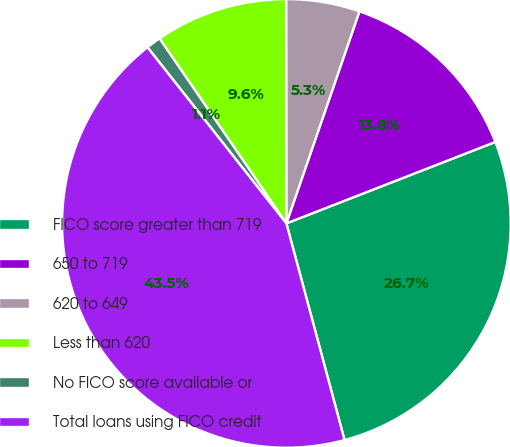Convert chart to OTSL. <chart><loc_0><loc_0><loc_500><loc_500><pie_chart><fcel>FICO score greater than 719<fcel>650 to 719<fcel>620 to 649<fcel>Less than 620<fcel>No FICO score available or<fcel>Total loans using FICO credit<nl><fcel>26.74%<fcel>13.8%<fcel>5.3%<fcel>9.55%<fcel>1.06%<fcel>43.54%<nl></chart> 